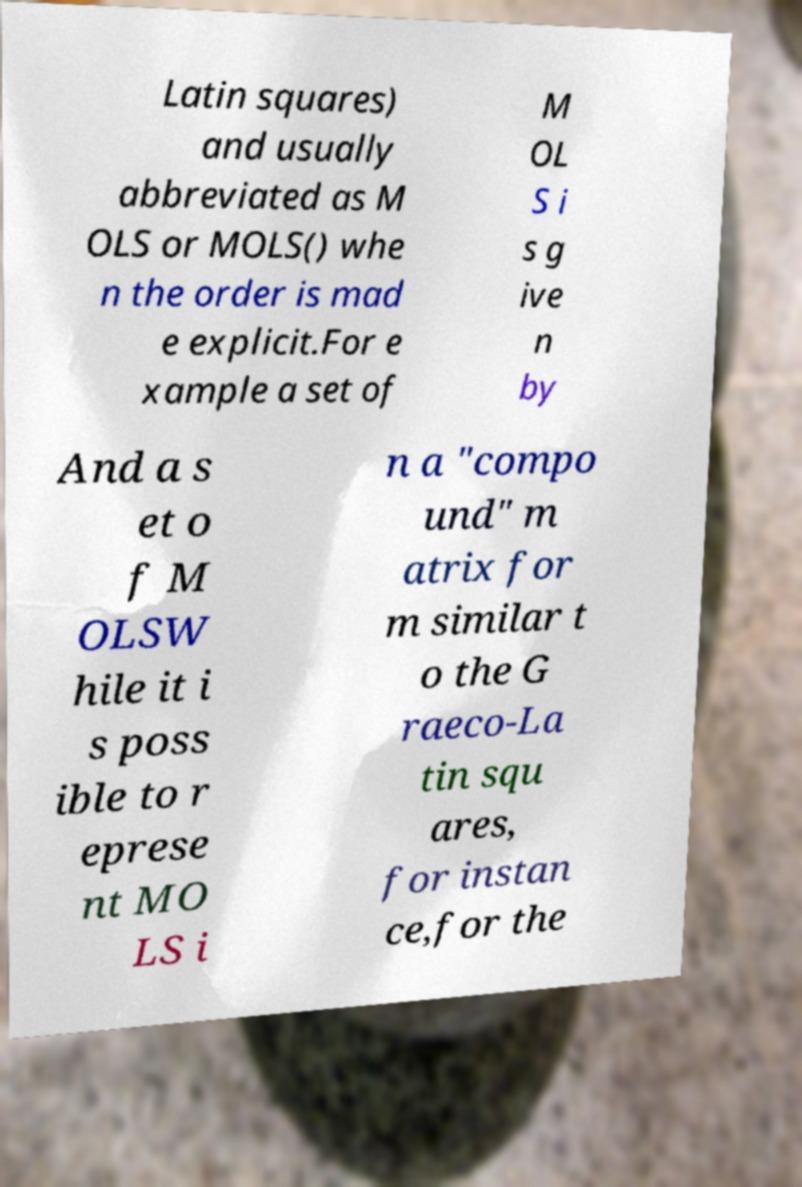What messages or text are displayed in this image? I need them in a readable, typed format. Latin squares) and usually abbreviated as M OLS or MOLS() whe n the order is mad e explicit.For e xample a set of M OL S i s g ive n by And a s et o f M OLSW hile it i s poss ible to r eprese nt MO LS i n a "compo und" m atrix for m similar t o the G raeco-La tin squ ares, for instan ce,for the 